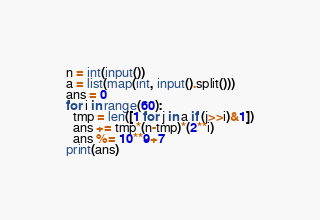Convert code to text. <code><loc_0><loc_0><loc_500><loc_500><_Python_>n = int(input())
a = list(map(int, input().split()))
ans = 0
for i in range(60):
  tmp = len([1 for j in a if (j>>i)&1])
  ans += tmp*(n-tmp)*(2**i)
  ans %= 10**9+7
print(ans)</code> 